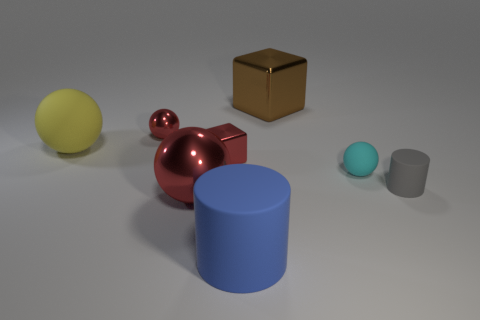Is there a cylinder of the same size as the cyan rubber ball?
Offer a terse response. Yes. Is the size of the gray matte cylinder that is right of the yellow matte object the same as the cyan matte object?
Make the answer very short. Yes. Is the number of small yellow metallic cubes greater than the number of brown things?
Provide a succinct answer. No. Are there any blue matte things of the same shape as the tiny cyan rubber object?
Offer a very short reply. No. There is a small red metal object in front of the small shiny sphere; what shape is it?
Your answer should be compact. Cube. There is a block on the right side of the metal block to the left of the large brown shiny object; what number of big shiny objects are in front of it?
Your answer should be very brief. 1. Does the cylinder behind the big cylinder have the same color as the big cylinder?
Ensure brevity in your answer.  No. How many other objects are the same shape as the cyan thing?
Your answer should be compact. 3. What number of other things are the same material as the large red ball?
Provide a succinct answer. 3. What is the small cube that is in front of the block behind the large matte thing that is behind the gray rubber thing made of?
Ensure brevity in your answer.  Metal. 